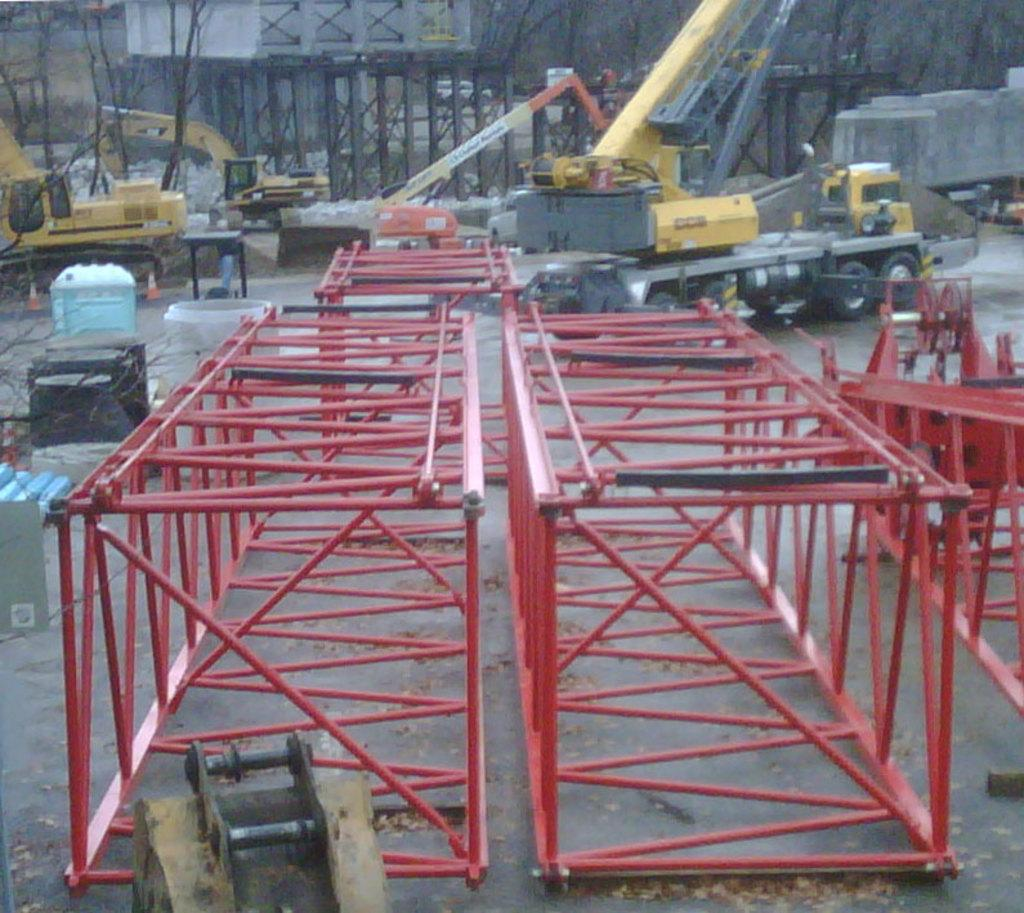What type of objects can be seen in the image? There are iron objects in the image. What can be seen in the background of the image? There are cranes in the background of the image. How many houses were built by the brothers in the image? There are no houses or brothers mentioned in the image; it only features iron objects and cranes in the background. 